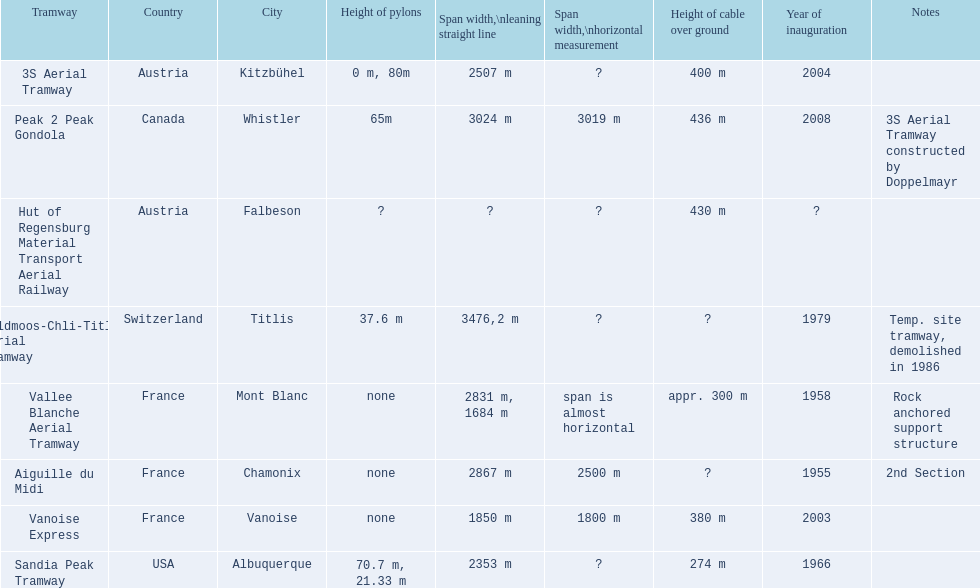Give me the full table as a dictionary. {'header': ['Tramway', 'Country', 'City', 'Height of pylons', 'Span\xa0width,\\nleaning straight line', 'Span width,\\nhorizontal measurement', 'Height of cable over ground', 'Year of inauguration', 'Notes'], 'rows': [['3S Aerial Tramway', 'Austria', 'Kitzbühel', '0 m, 80m', '2507 m', '?', '400 m', '2004', ''], ['Peak 2 Peak Gondola', 'Canada', 'Whistler', '65m', '3024 m', '3019 m', '436 m', '2008', '3S Aerial Tramway constructed by Doppelmayr'], ['Hut of Regensburg Material Transport Aerial Railway', 'Austria', 'Falbeson', '?', '?', '?', '430 m', '?', ''], ['Feldmoos-Chli-Titlis Aerial Tramway', 'Switzerland', 'Titlis', '37.6 m', '3476,2 m', '?', '?', '1979', 'Temp. site tramway, demolished in 1986'], ['Vallee Blanche Aerial Tramway', 'France', 'Mont Blanc', 'none', '2831 m, 1684 m', 'span is almost horizontal', 'appr. 300 m', '1958', 'Rock anchored support structure'], ['Aiguille du Midi', 'France', 'Chamonix', 'none', '2867 m', '2500 m', '?', '1955', '2nd Section'], ['Vanoise Express', 'France', 'Vanoise', 'none', '1850 m', '1800 m', '380 m', '2003', ''], ['Sandia Peak Tramway', 'USA', 'Albuquerque', '70.7 m, 21.33 m', '2353 m', '?', '274 m', '1966', '']]} Which tramway was established directly before the 3s aerial tramway? Vanoise Express. 